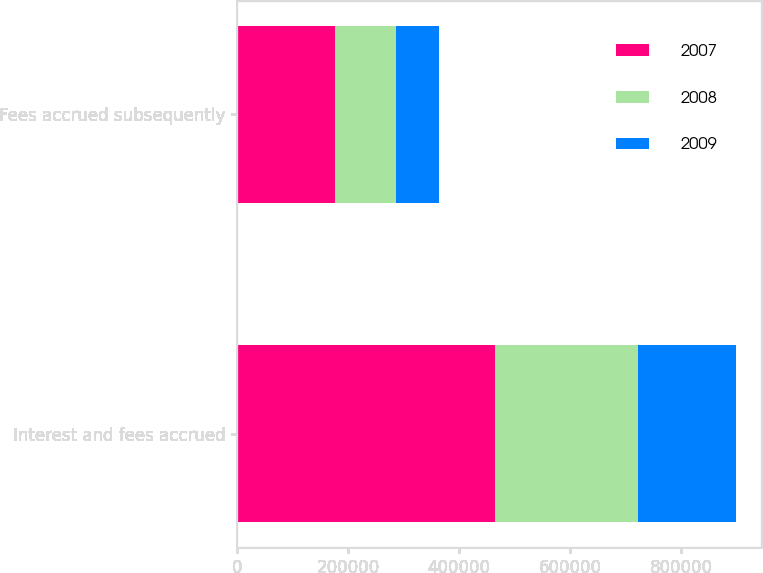Convert chart to OTSL. <chart><loc_0><loc_0><loc_500><loc_500><stacked_bar_chart><ecel><fcel>Interest and fees accrued<fcel>Fees accrued subsequently<nl><fcel>2007<fcel>465283<fcel>176662<nl><fcel>2008<fcel>257543<fcel>108976<nl><fcel>2009<fcel>175383<fcel>78100<nl></chart> 